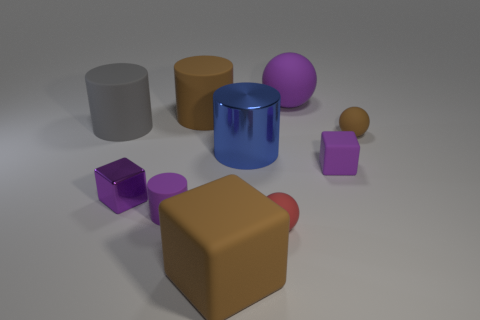How many big red cylinders are made of the same material as the brown sphere?
Your answer should be very brief. 0. The big block that is the same material as the big sphere is what color?
Your answer should be compact. Brown. Is the shape of the large metallic thing the same as the big purple rubber thing?
Your response must be concise. No. Is there a small brown ball that is on the right side of the big gray object behind the tiny rubber sphere right of the purple sphere?
Your answer should be very brief. Yes. What number of big spheres have the same color as the tiny matte cylinder?
Offer a very short reply. 1. There is a blue thing that is the same size as the purple sphere; what shape is it?
Make the answer very short. Cylinder. There is a purple matte cube; are there any small purple objects to the left of it?
Ensure brevity in your answer.  Yes. Is the blue cylinder the same size as the red matte ball?
Offer a very short reply. No. What shape is the big brown object behind the gray rubber thing?
Offer a terse response. Cylinder. Is there another gray object that has the same size as the gray matte thing?
Give a very brief answer. No. 